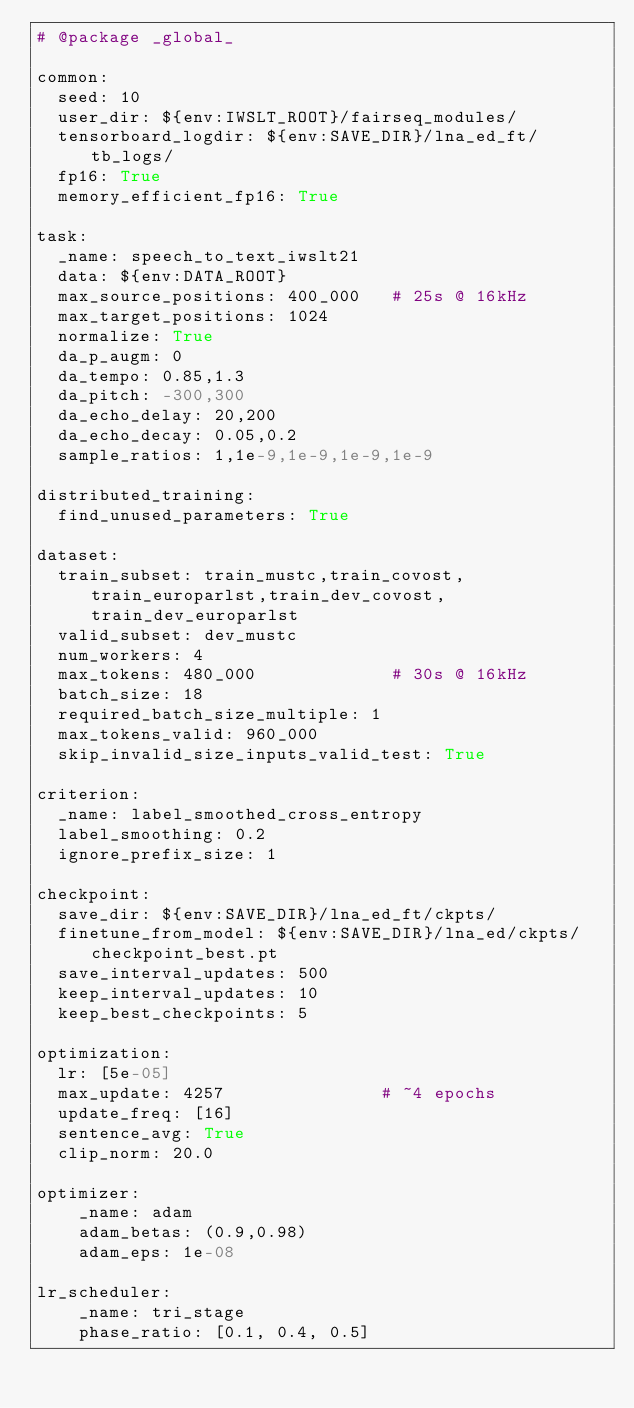<code> <loc_0><loc_0><loc_500><loc_500><_YAML_># @package _global_

common:
  seed: 10
  user_dir: ${env:IWSLT_ROOT}/fairseq_modules/
  tensorboard_logdir: ${env:SAVE_DIR}/lna_ed_ft/tb_logs/
  fp16: True
  memory_efficient_fp16: True

task:
  _name: speech_to_text_iwslt21
  data: ${env:DATA_ROOT}
  max_source_positions: 400_000   # 25s @ 16kHz
  max_target_positions: 1024
  normalize: True
  da_p_augm: 0
  da_tempo: 0.85,1.3
  da_pitch: -300,300
  da_echo_delay: 20,200
  da_echo_decay: 0.05,0.2
  sample_ratios: 1,1e-9,1e-9,1e-9,1e-9

distributed_training:
  find_unused_parameters: True

dataset:
  train_subset: train_mustc,train_covost,train_europarlst,train_dev_covost,train_dev_europarlst
  valid_subset: dev_mustc
  num_workers: 4
  max_tokens: 480_000             # 30s @ 16kHz
  batch_size: 18
  required_batch_size_multiple: 1
  max_tokens_valid: 960_000
  skip_invalid_size_inputs_valid_test: True

criterion:
  _name: label_smoothed_cross_entropy
  label_smoothing: 0.2
  ignore_prefix_size: 1

checkpoint:
  save_dir: ${env:SAVE_DIR}/lna_ed_ft/ckpts/
  finetune_from_model: ${env:SAVE_DIR}/lna_ed/ckpts/checkpoint_best.pt
  save_interval_updates: 500
  keep_interval_updates: 10
  keep_best_checkpoints: 5

optimization:
  lr: [5e-05]
  max_update: 4257               # ~4 epochs
  update_freq: [16]
  sentence_avg: True
  clip_norm: 20.0

optimizer:
    _name: adam
    adam_betas: (0.9,0.98)
    adam_eps: 1e-08

lr_scheduler:
    _name: tri_stage
    phase_ratio: [0.1, 0.4, 0.5]</code> 